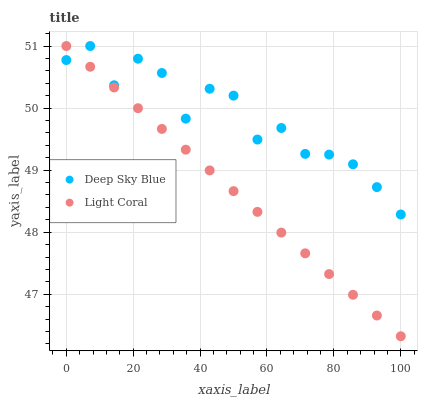Does Light Coral have the minimum area under the curve?
Answer yes or no. Yes. Does Deep Sky Blue have the maximum area under the curve?
Answer yes or no. Yes. Does Deep Sky Blue have the minimum area under the curve?
Answer yes or no. No. Is Light Coral the smoothest?
Answer yes or no. Yes. Is Deep Sky Blue the roughest?
Answer yes or no. Yes. Is Deep Sky Blue the smoothest?
Answer yes or no. No. Does Light Coral have the lowest value?
Answer yes or no. Yes. Does Deep Sky Blue have the lowest value?
Answer yes or no. No. Does Deep Sky Blue have the highest value?
Answer yes or no. Yes. Does Light Coral intersect Deep Sky Blue?
Answer yes or no. Yes. Is Light Coral less than Deep Sky Blue?
Answer yes or no. No. Is Light Coral greater than Deep Sky Blue?
Answer yes or no. No. 